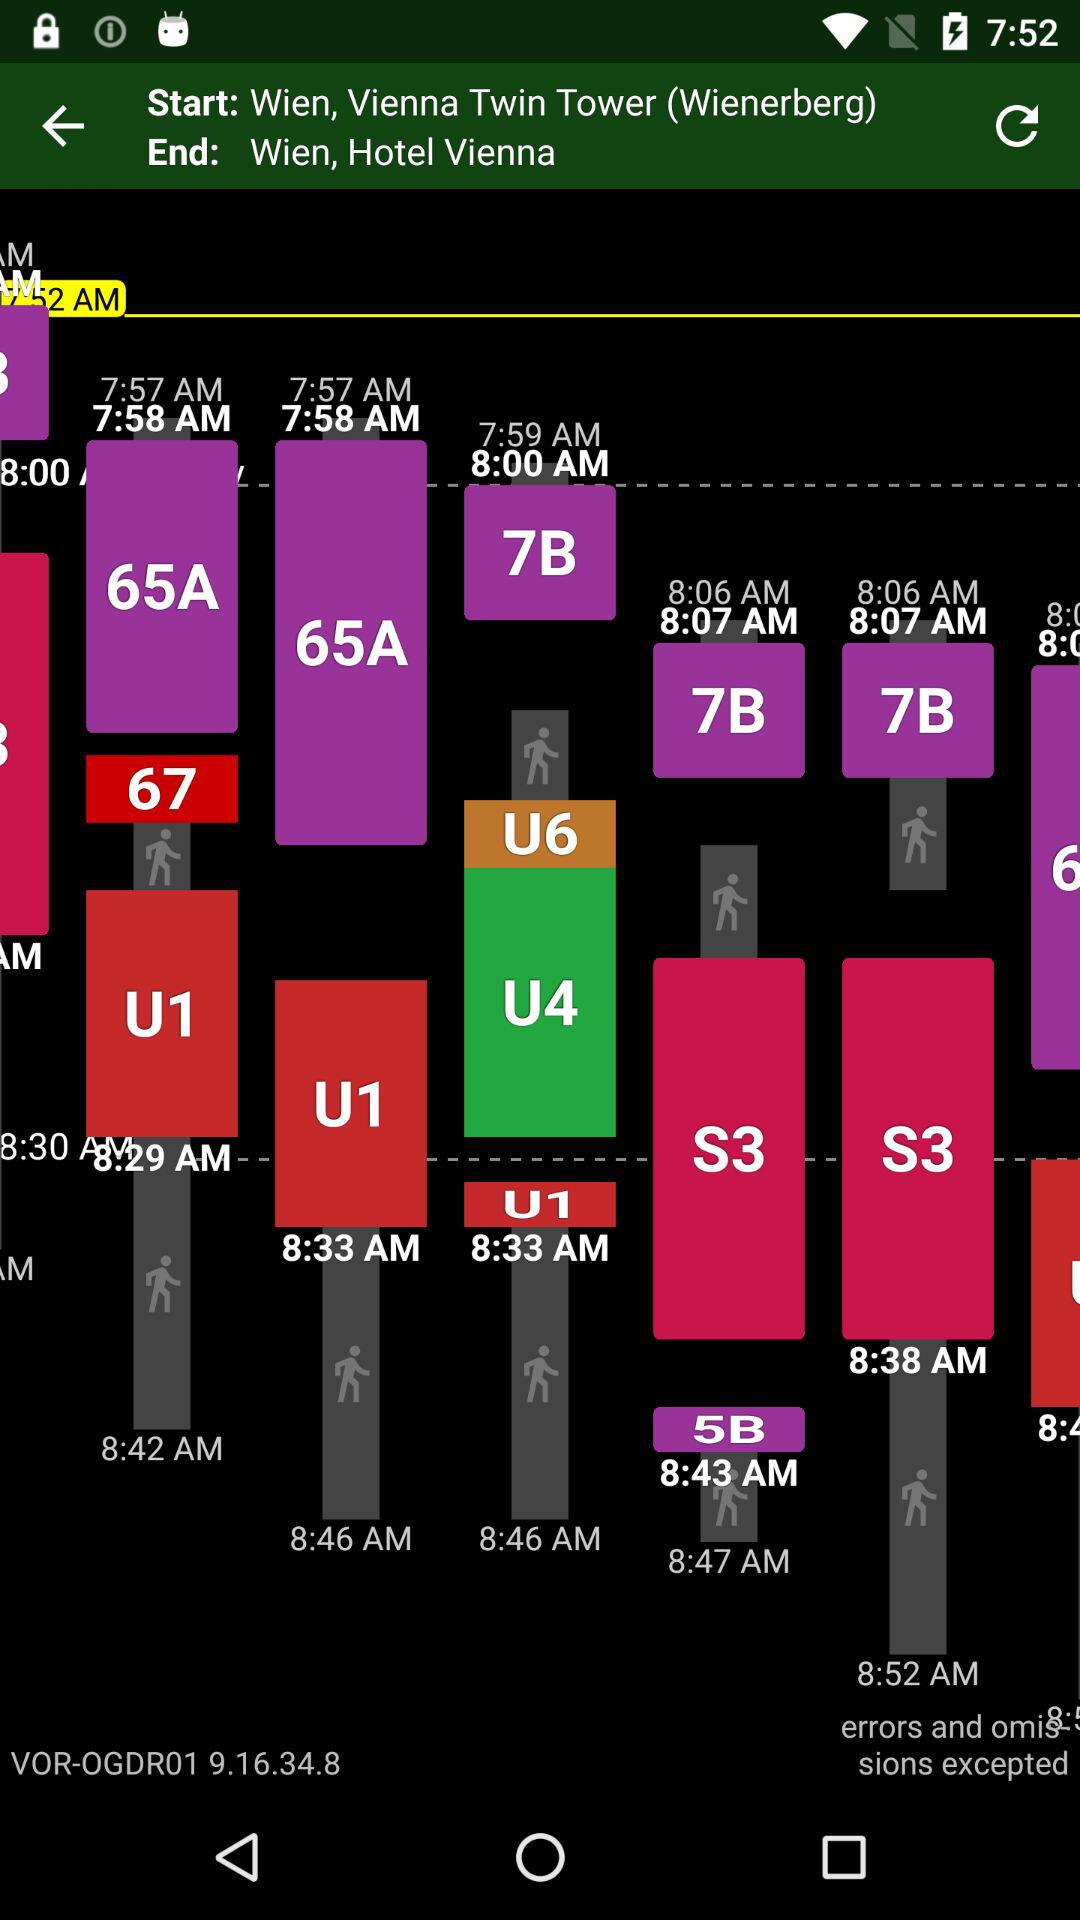How many minutes are there between the 8:00 and 8:06 times?
Answer the question using a single word or phrase. 6 